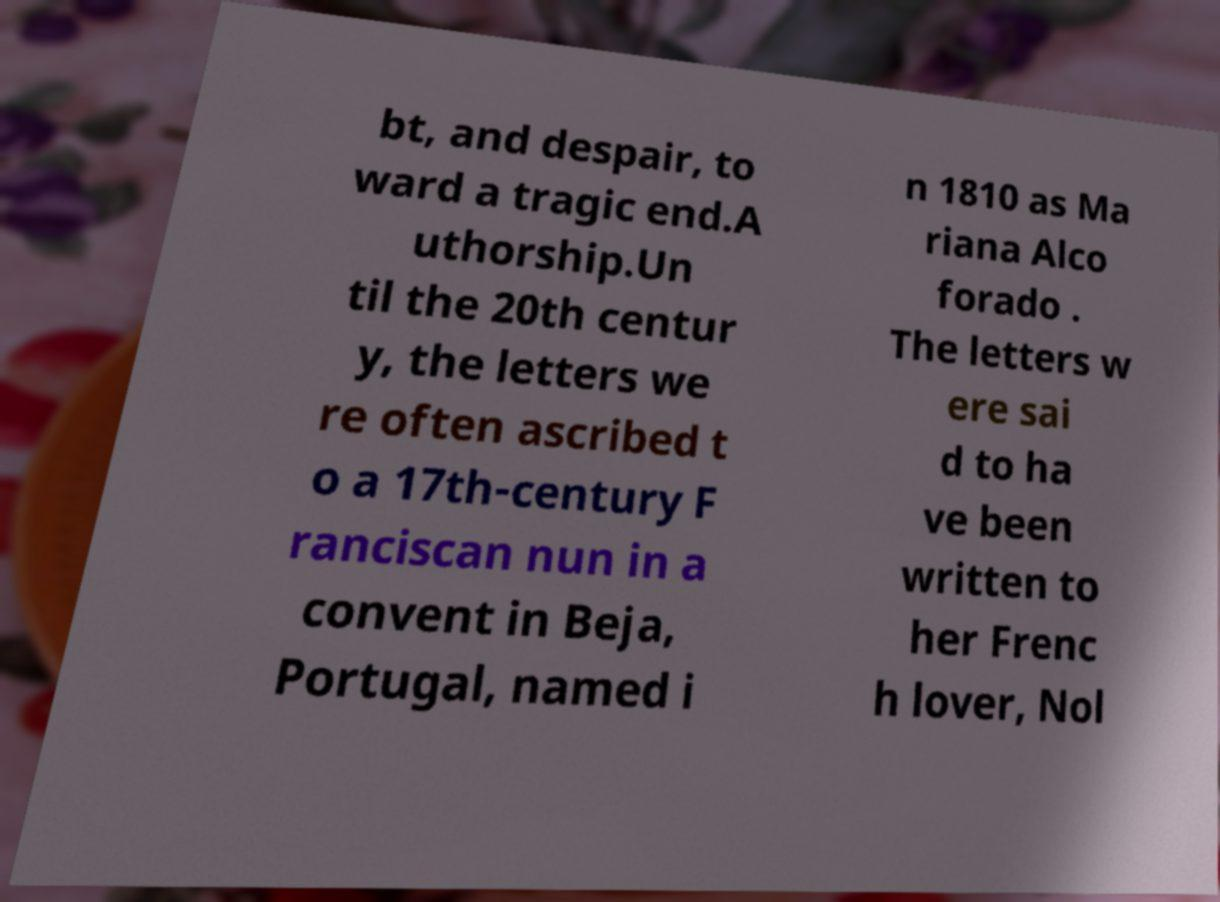What messages or text are displayed in this image? I need them in a readable, typed format. bt, and despair, to ward a tragic end.A uthorship.Un til the 20th centur y, the letters we re often ascribed t o a 17th-century F ranciscan nun in a convent in Beja, Portugal, named i n 1810 as Ma riana Alco forado . The letters w ere sai d to ha ve been written to her Frenc h lover, Nol 